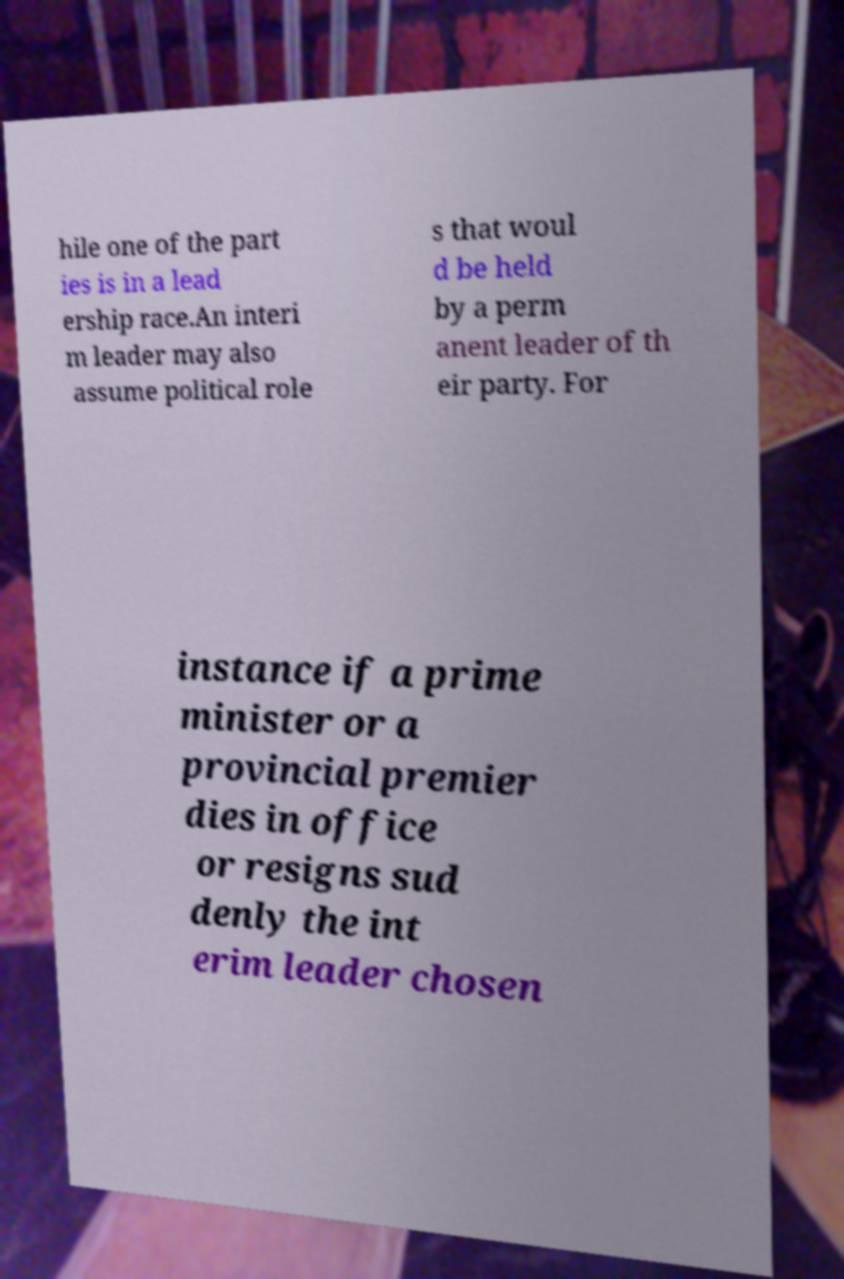For documentation purposes, I need the text within this image transcribed. Could you provide that? hile one of the part ies is in a lead ership race.An interi m leader may also assume political role s that woul d be held by a perm anent leader of th eir party. For instance if a prime minister or a provincial premier dies in office or resigns sud denly the int erim leader chosen 